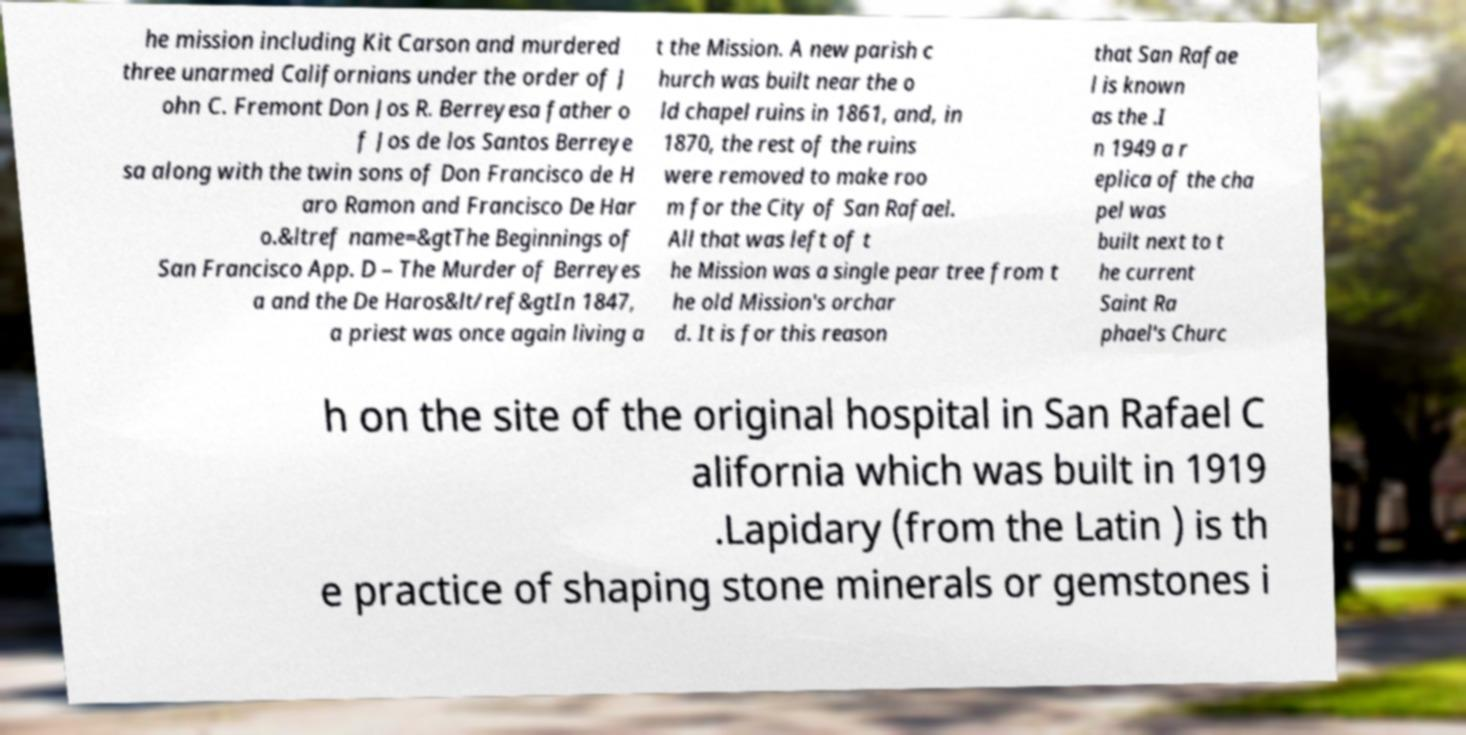I need the written content from this picture converted into text. Can you do that? he mission including Kit Carson and murdered three unarmed Californians under the order of J ohn C. Fremont Don Jos R. Berreyesa father o f Jos de los Santos Berreye sa along with the twin sons of Don Francisco de H aro Ramon and Francisco De Har o.&ltref name=&gtThe Beginnings of San Francisco App. D – The Murder of Berreyes a and the De Haros&lt/ref&gtIn 1847, a priest was once again living a t the Mission. A new parish c hurch was built near the o ld chapel ruins in 1861, and, in 1870, the rest of the ruins were removed to make roo m for the City of San Rafael. All that was left of t he Mission was a single pear tree from t he old Mission's orchar d. It is for this reason that San Rafae l is known as the .I n 1949 a r eplica of the cha pel was built next to t he current Saint Ra phael's Churc h on the site of the original hospital in San Rafael C alifornia which was built in 1919 .Lapidary (from the Latin ) is th e practice of shaping stone minerals or gemstones i 